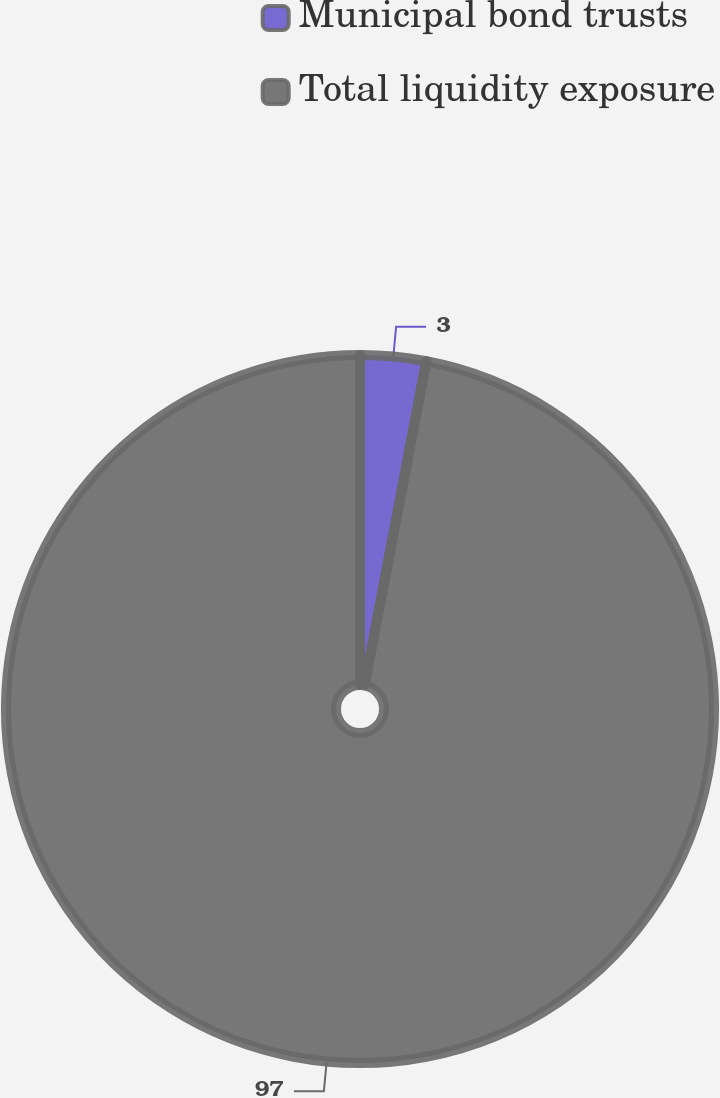Convert chart. <chart><loc_0><loc_0><loc_500><loc_500><pie_chart><fcel>Municipal bond trusts<fcel>Total liquidity exposure<nl><fcel>3.0%<fcel>97.0%<nl></chart> 